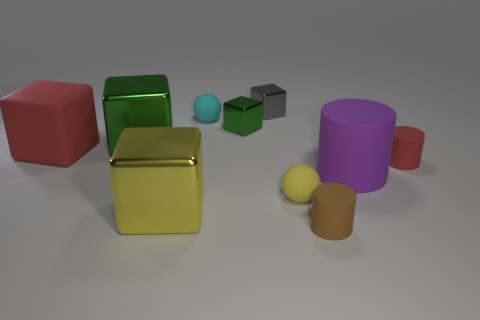Subtract all gray cubes. How many cubes are left? 4 Subtract all brown cylinders. How many cylinders are left? 2 Subtract 1 cylinders. How many cylinders are left? 2 Subtract all cyan cubes. Subtract all gray spheres. How many cubes are left? 5 Subtract all cyan balls. How many gray cubes are left? 1 Subtract all large green metal things. Subtract all small matte objects. How many objects are left? 5 Add 1 small cyan rubber spheres. How many small cyan rubber spheres are left? 2 Add 2 large metal cubes. How many large metal cubes exist? 4 Subtract 1 red blocks. How many objects are left? 9 Subtract all cylinders. How many objects are left? 7 